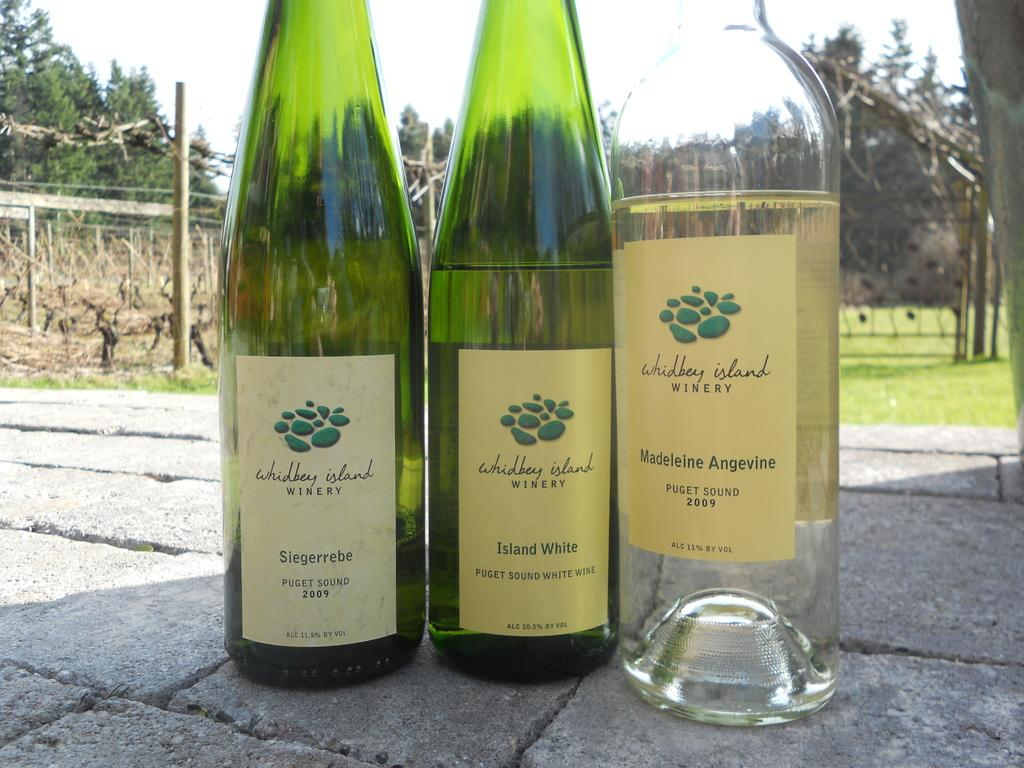<image>
Summarize the visual content of the image. Three bottles from the Whidbey island winery are on the ground outside. 